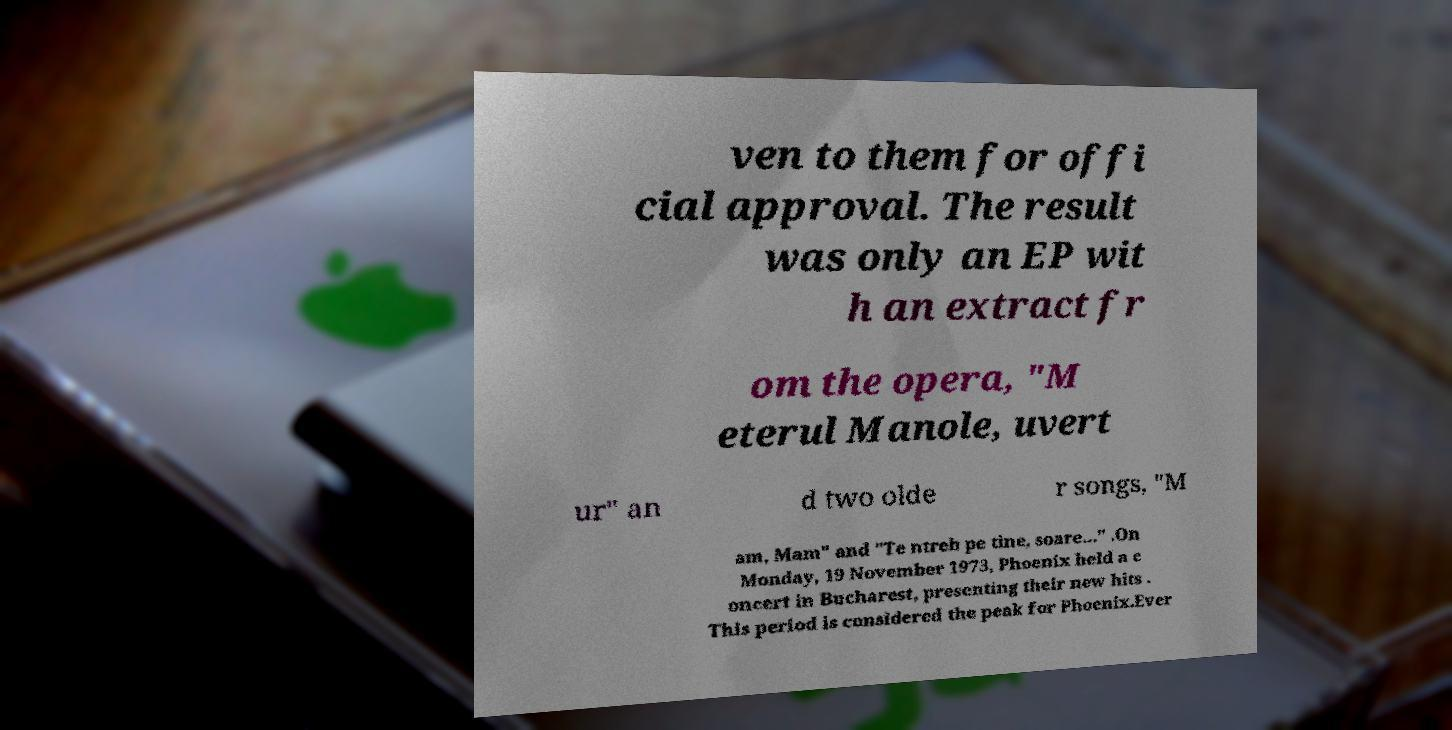What messages or text are displayed in this image? I need them in a readable, typed format. ven to them for offi cial approval. The result was only an EP wit h an extract fr om the opera, "M eterul Manole, uvert ur" an d two olde r songs, "M am, Mam" and "Te ntreb pe tine, soare..." .On Monday, 19 November 1973, Phoenix held a c oncert in Bucharest, presenting their new hits . This period is considered the peak for Phoenix.Ever 